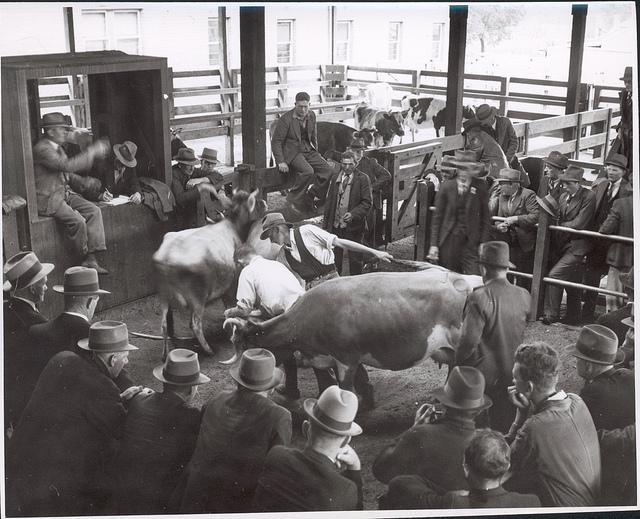How many cows can you see?
Give a very brief answer. 2. How many people can be seen?
Give a very brief answer. 11. 